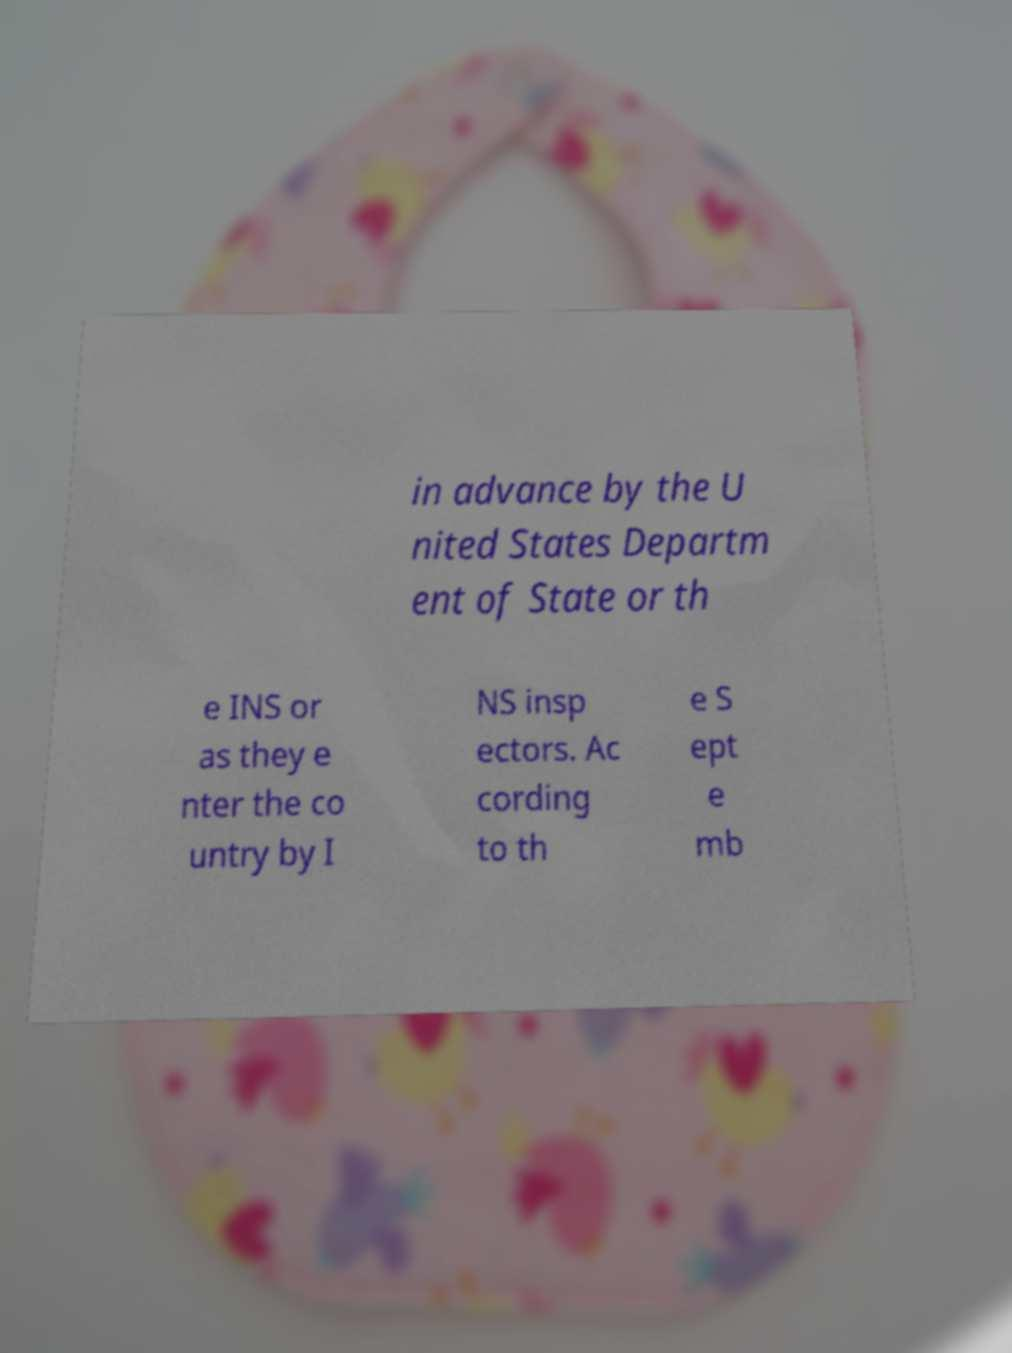Can you read and provide the text displayed in the image?This photo seems to have some interesting text. Can you extract and type it out for me? in advance by the U nited States Departm ent of State or th e INS or as they e nter the co untry by I NS insp ectors. Ac cording to th e S ept e mb 